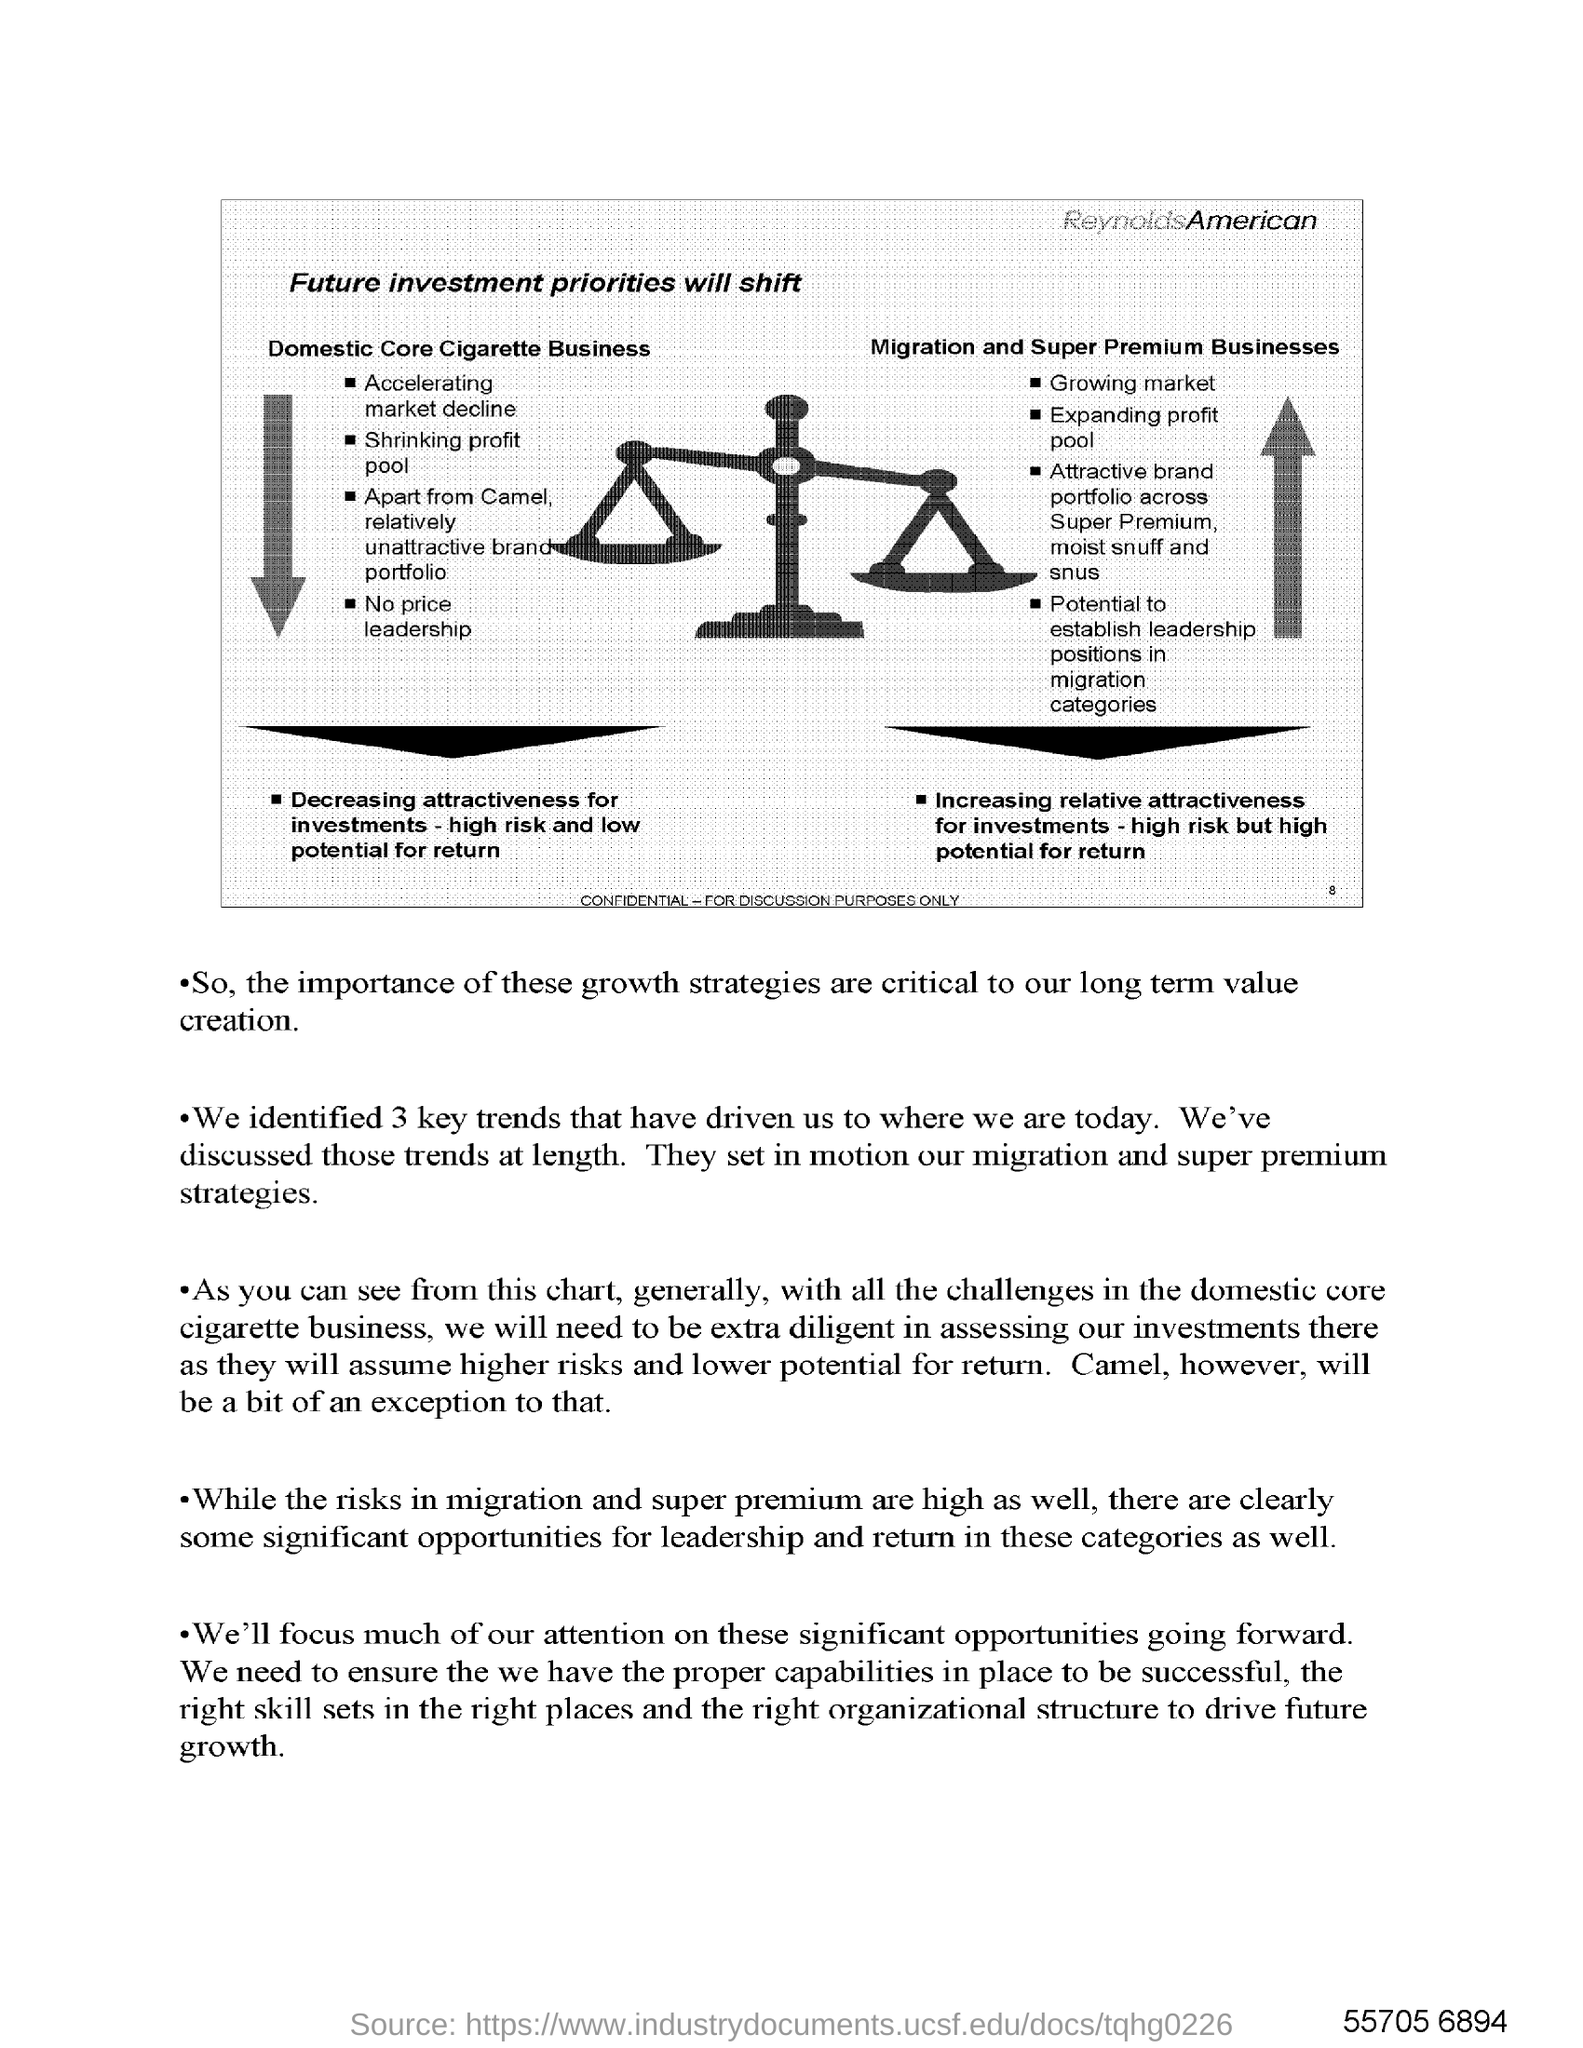What is the text written in the top right corner?
Provide a short and direct response. ReynoldsAmerican. 